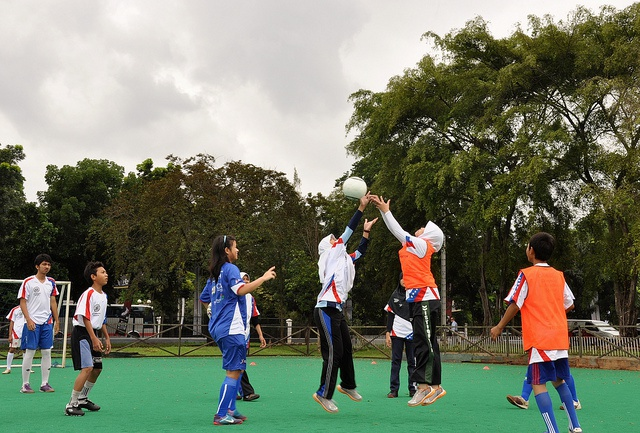Describe the objects in this image and their specific colors. I can see people in lightgray, red, black, and navy tones, people in lightgray, black, lavender, gray, and darkgray tones, people in lightgray, black, red, and darkgray tones, people in lightgray, blue, navy, black, and darkblue tones, and people in lightgray, black, gray, and brown tones in this image. 